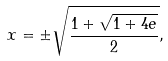<formula> <loc_0><loc_0><loc_500><loc_500>x = \pm \sqrt { \frac { 1 + \sqrt { 1 + 4 e } } { 2 } } ,</formula> 